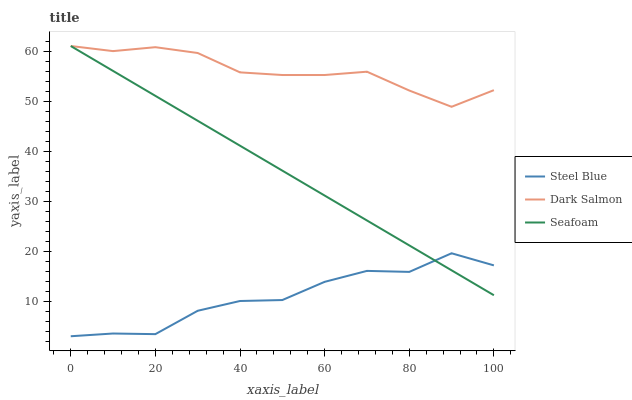Does Steel Blue have the minimum area under the curve?
Answer yes or no. Yes. Does Dark Salmon have the maximum area under the curve?
Answer yes or no. Yes. Does Dark Salmon have the minimum area under the curve?
Answer yes or no. No. Does Steel Blue have the maximum area under the curve?
Answer yes or no. No. Is Seafoam the smoothest?
Answer yes or no. Yes. Is Steel Blue the roughest?
Answer yes or no. Yes. Is Dark Salmon the smoothest?
Answer yes or no. No. Is Dark Salmon the roughest?
Answer yes or no. No. Does Steel Blue have the lowest value?
Answer yes or no. Yes. Does Dark Salmon have the lowest value?
Answer yes or no. No. Does Dark Salmon have the highest value?
Answer yes or no. Yes. Does Steel Blue have the highest value?
Answer yes or no. No. Is Steel Blue less than Dark Salmon?
Answer yes or no. Yes. Is Dark Salmon greater than Steel Blue?
Answer yes or no. Yes. Does Seafoam intersect Steel Blue?
Answer yes or no. Yes. Is Seafoam less than Steel Blue?
Answer yes or no. No. Is Seafoam greater than Steel Blue?
Answer yes or no. No. Does Steel Blue intersect Dark Salmon?
Answer yes or no. No. 